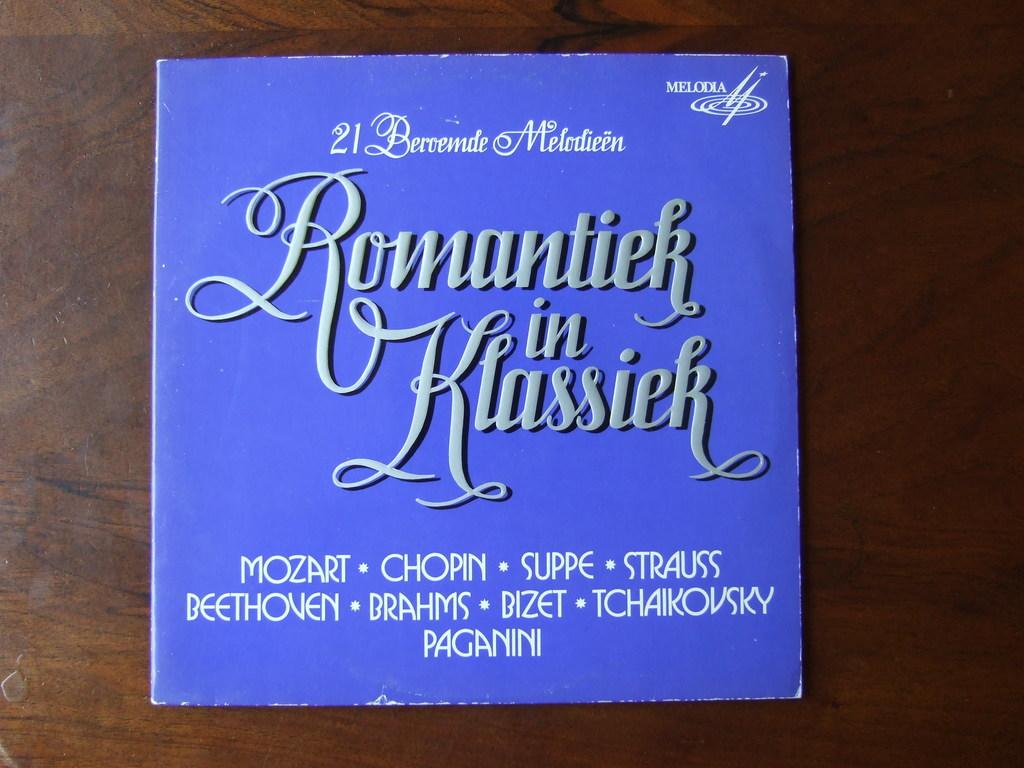What kind of book is it?
Offer a terse response. Melodia. What is the book all about?
Make the answer very short. Unanswerable. 